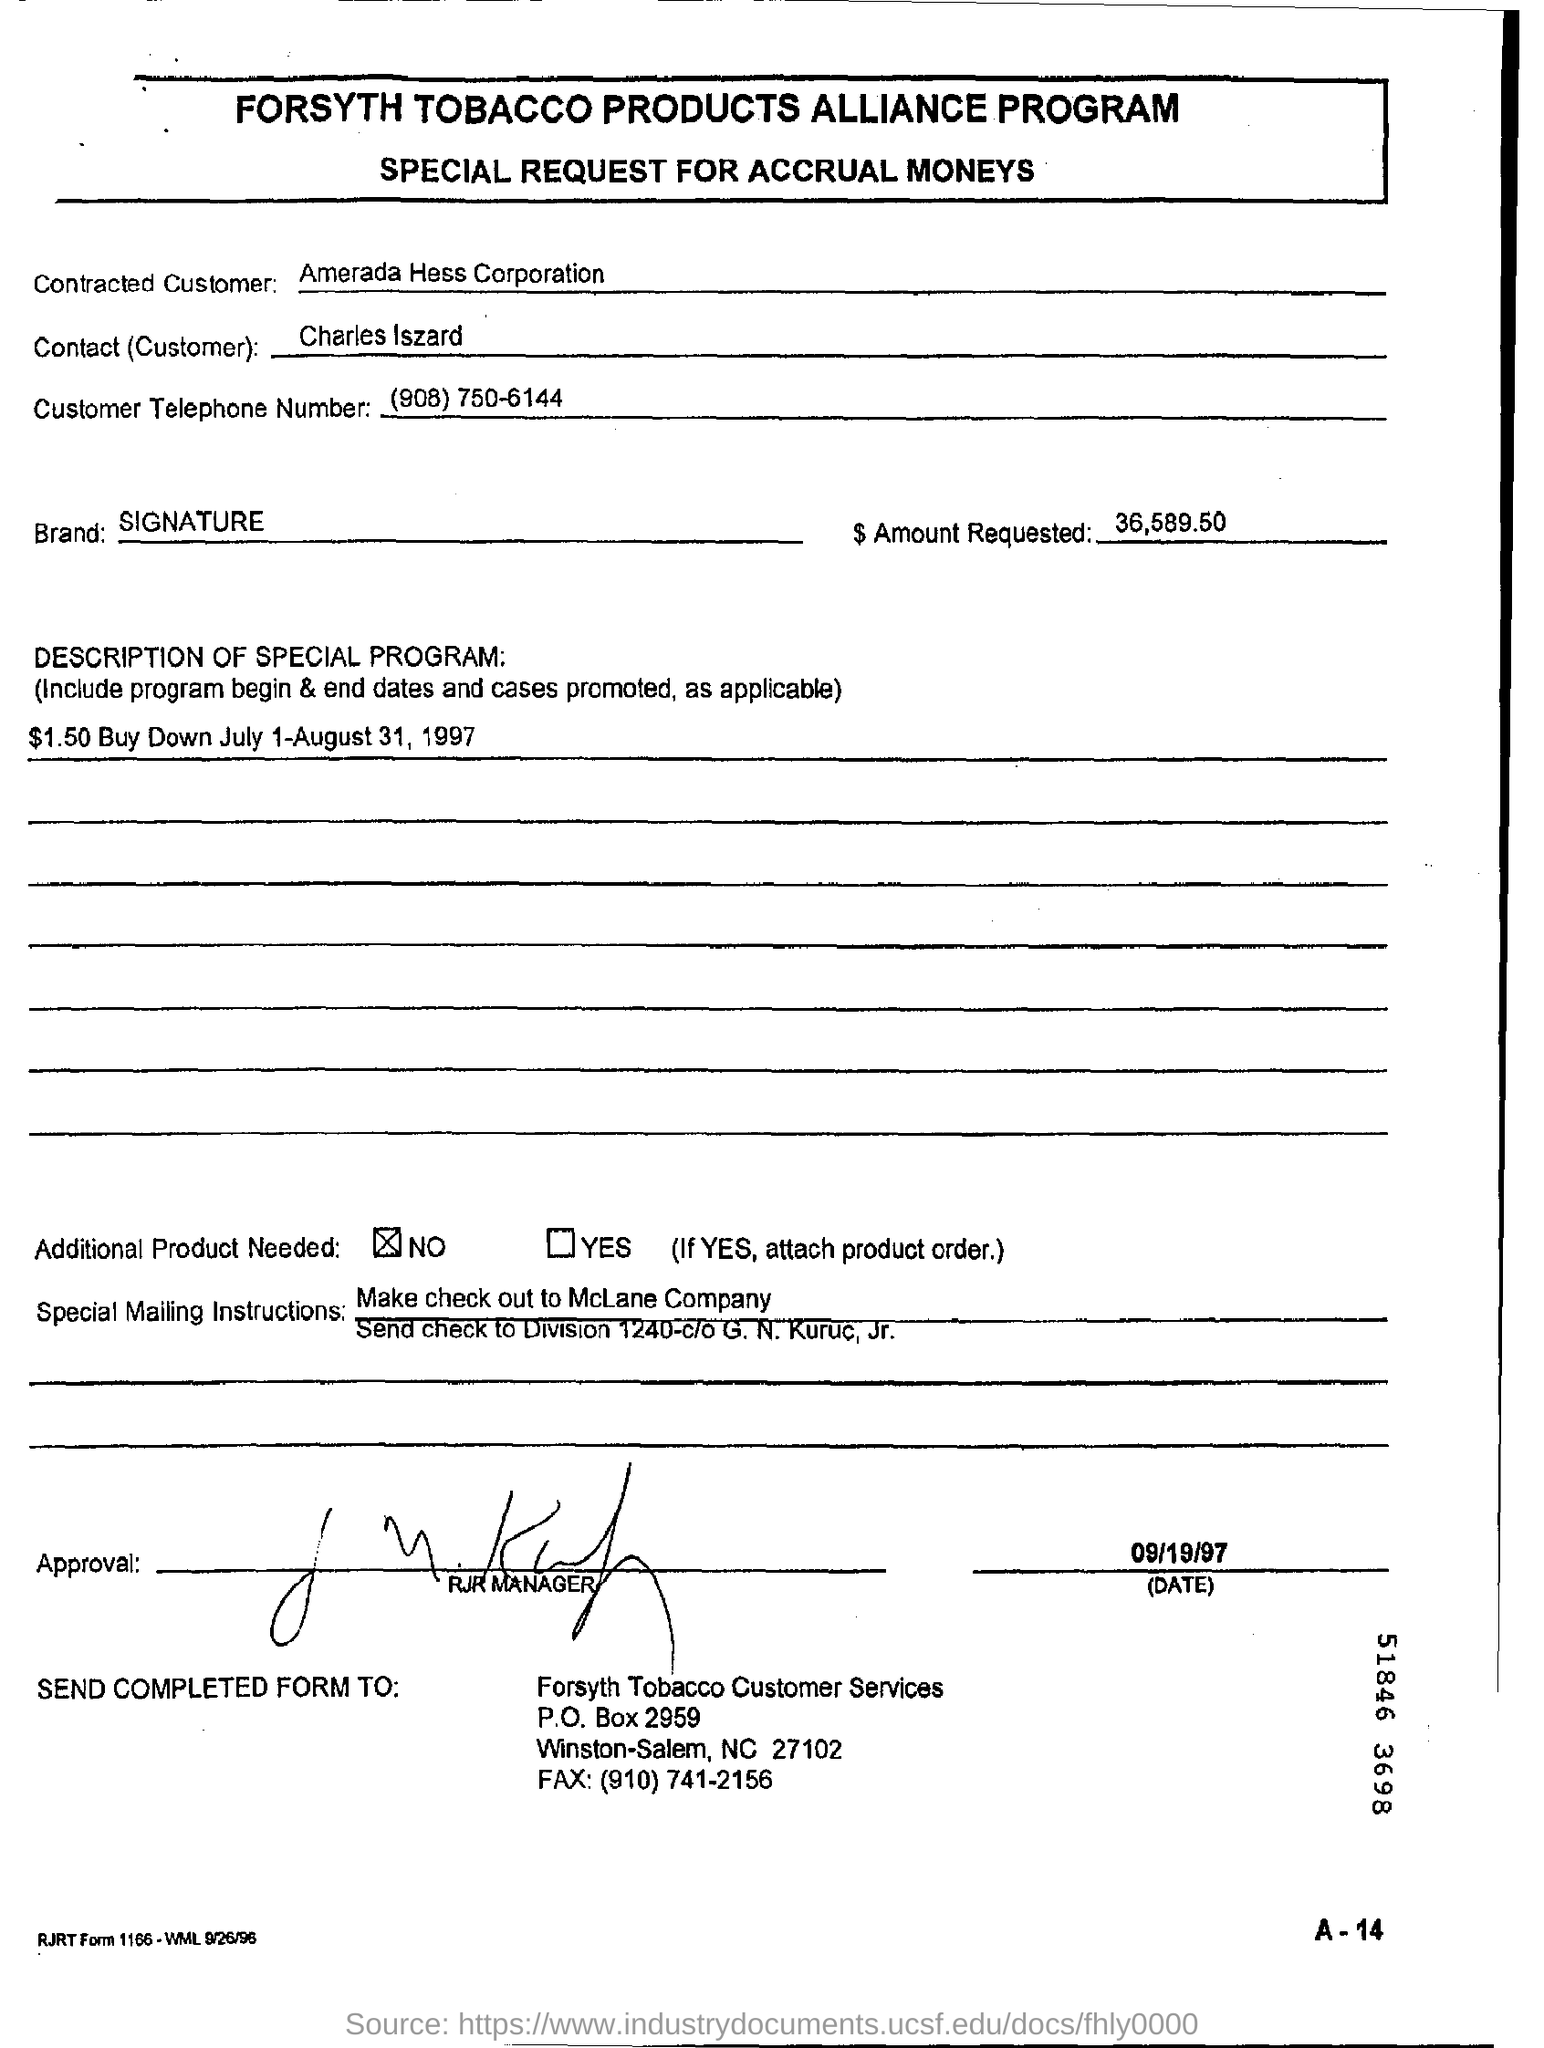What is the customer Telephone Number given?
Your answer should be compact. (908) 750-6144. What is the Amount Requested?
Give a very brief answer. 36,589.50. What is the Brand mentioned in the document?
Your answer should be compact. Signature. What is Date of Approval?
Offer a terse response. 09/19/97. Who gave Approval?
Ensure brevity in your answer.  RJR MANAGER. 